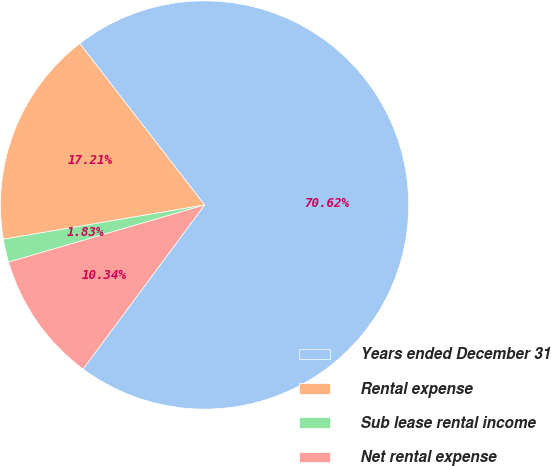Convert chart to OTSL. <chart><loc_0><loc_0><loc_500><loc_500><pie_chart><fcel>Years ended December 31<fcel>Rental expense<fcel>Sub lease rental income<fcel>Net rental expense<nl><fcel>70.62%<fcel>17.21%<fcel>1.83%<fcel>10.34%<nl></chart> 